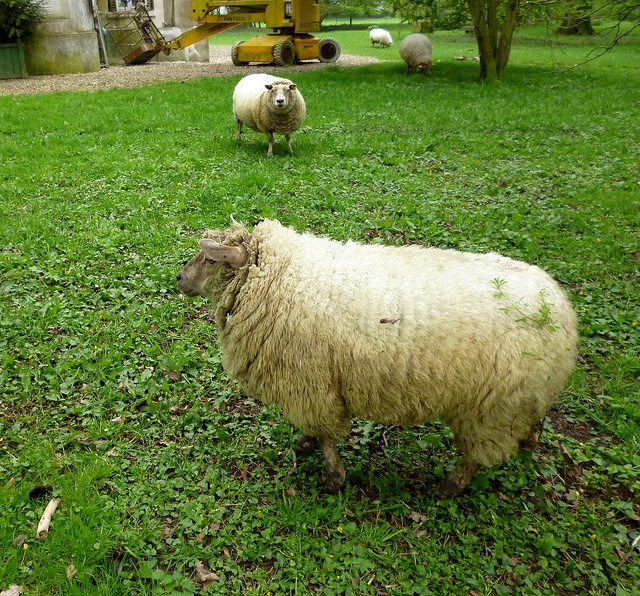Describe the objects in this image and their specific colors. I can see sheep in darkgreen, olive, tan, and beige tones, sheep in darkgreen, ivory, olive, and black tones, sheep in darkgreen, gray, olive, and darkgray tones, and sheep in darkgreen, ivory, olive, and beige tones in this image. 